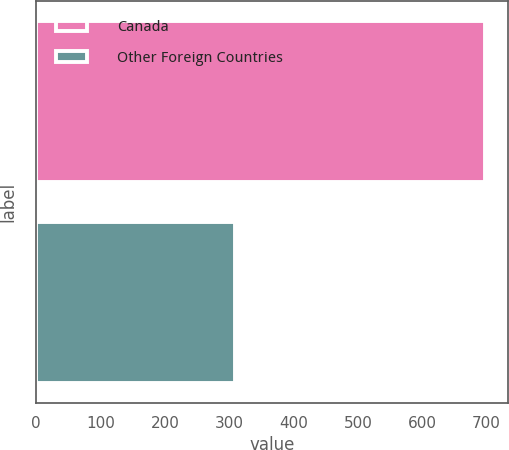<chart> <loc_0><loc_0><loc_500><loc_500><bar_chart><fcel>Canada<fcel>Other Foreign Countries<nl><fcel>698<fcel>309<nl></chart> 